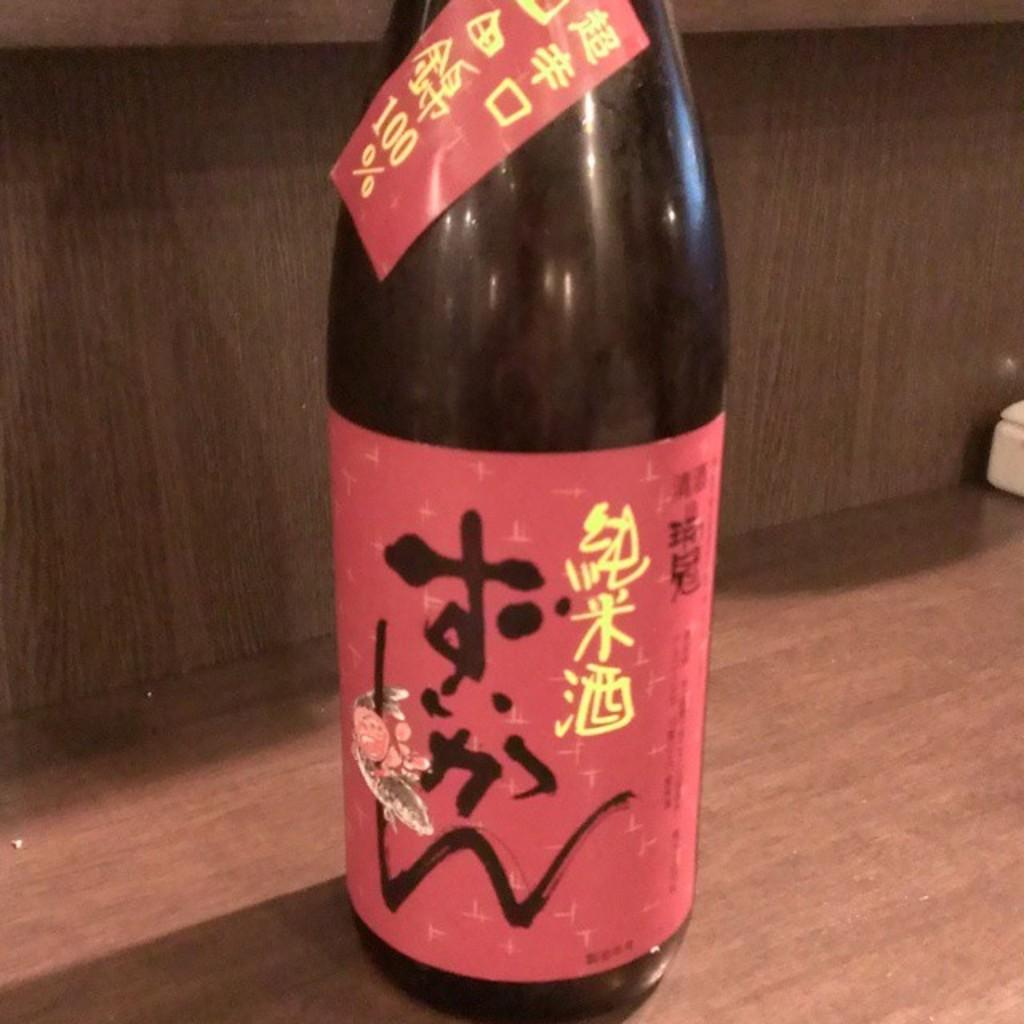<image>
Present a compact description of the photo's key features. Red labeled dark bottle with 100 percent on the top 